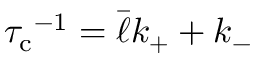Convert formula to latex. <formula><loc_0><loc_0><loc_500><loc_500>{ \tau _ { c } } ^ { - 1 } = \bar { \ell } k _ { + } + k _ { - }</formula> 